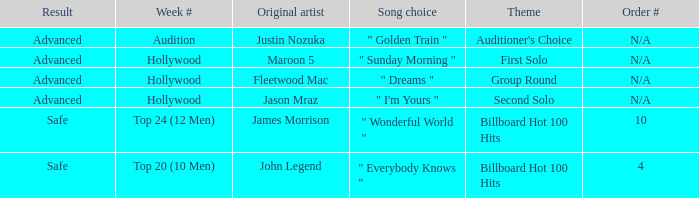What are all the topic wherein music preference is " golden train " Auditioner's Choice. 